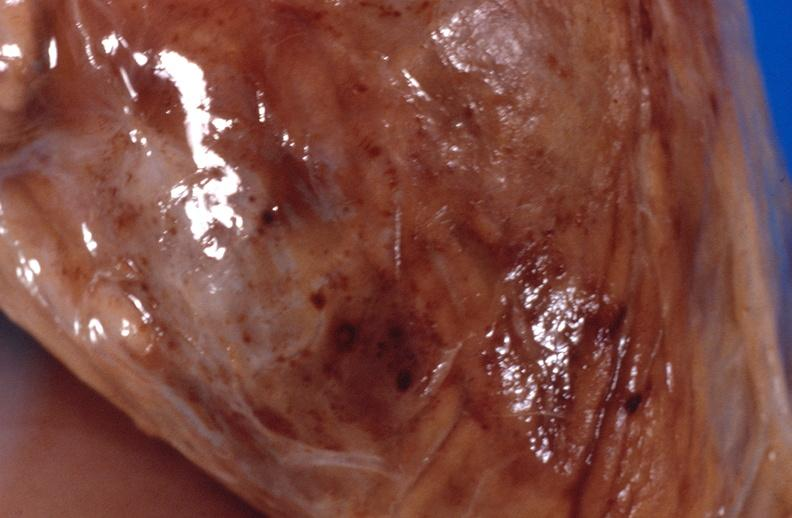does this image show panniculitis and fascitis?
Answer the question using a single word or phrase. Yes 